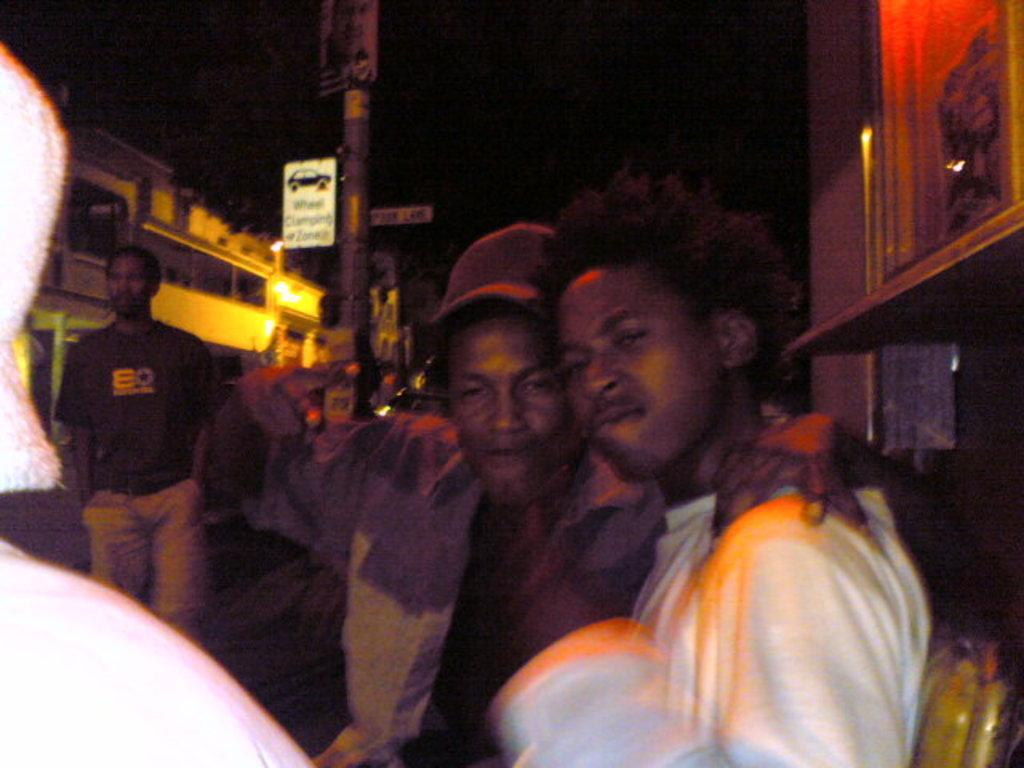How many men are in the image? There are two men standing together in the image. What can be seen in the background of the image? There is a pole visible in the background of the image, and there is a man standing near the pole. Additionally, there are houses visible in the background. What type of holiday are the men celebrating in the image? There is no indication of a holiday in the image; it simply shows two men standing together and other elements in the background. 